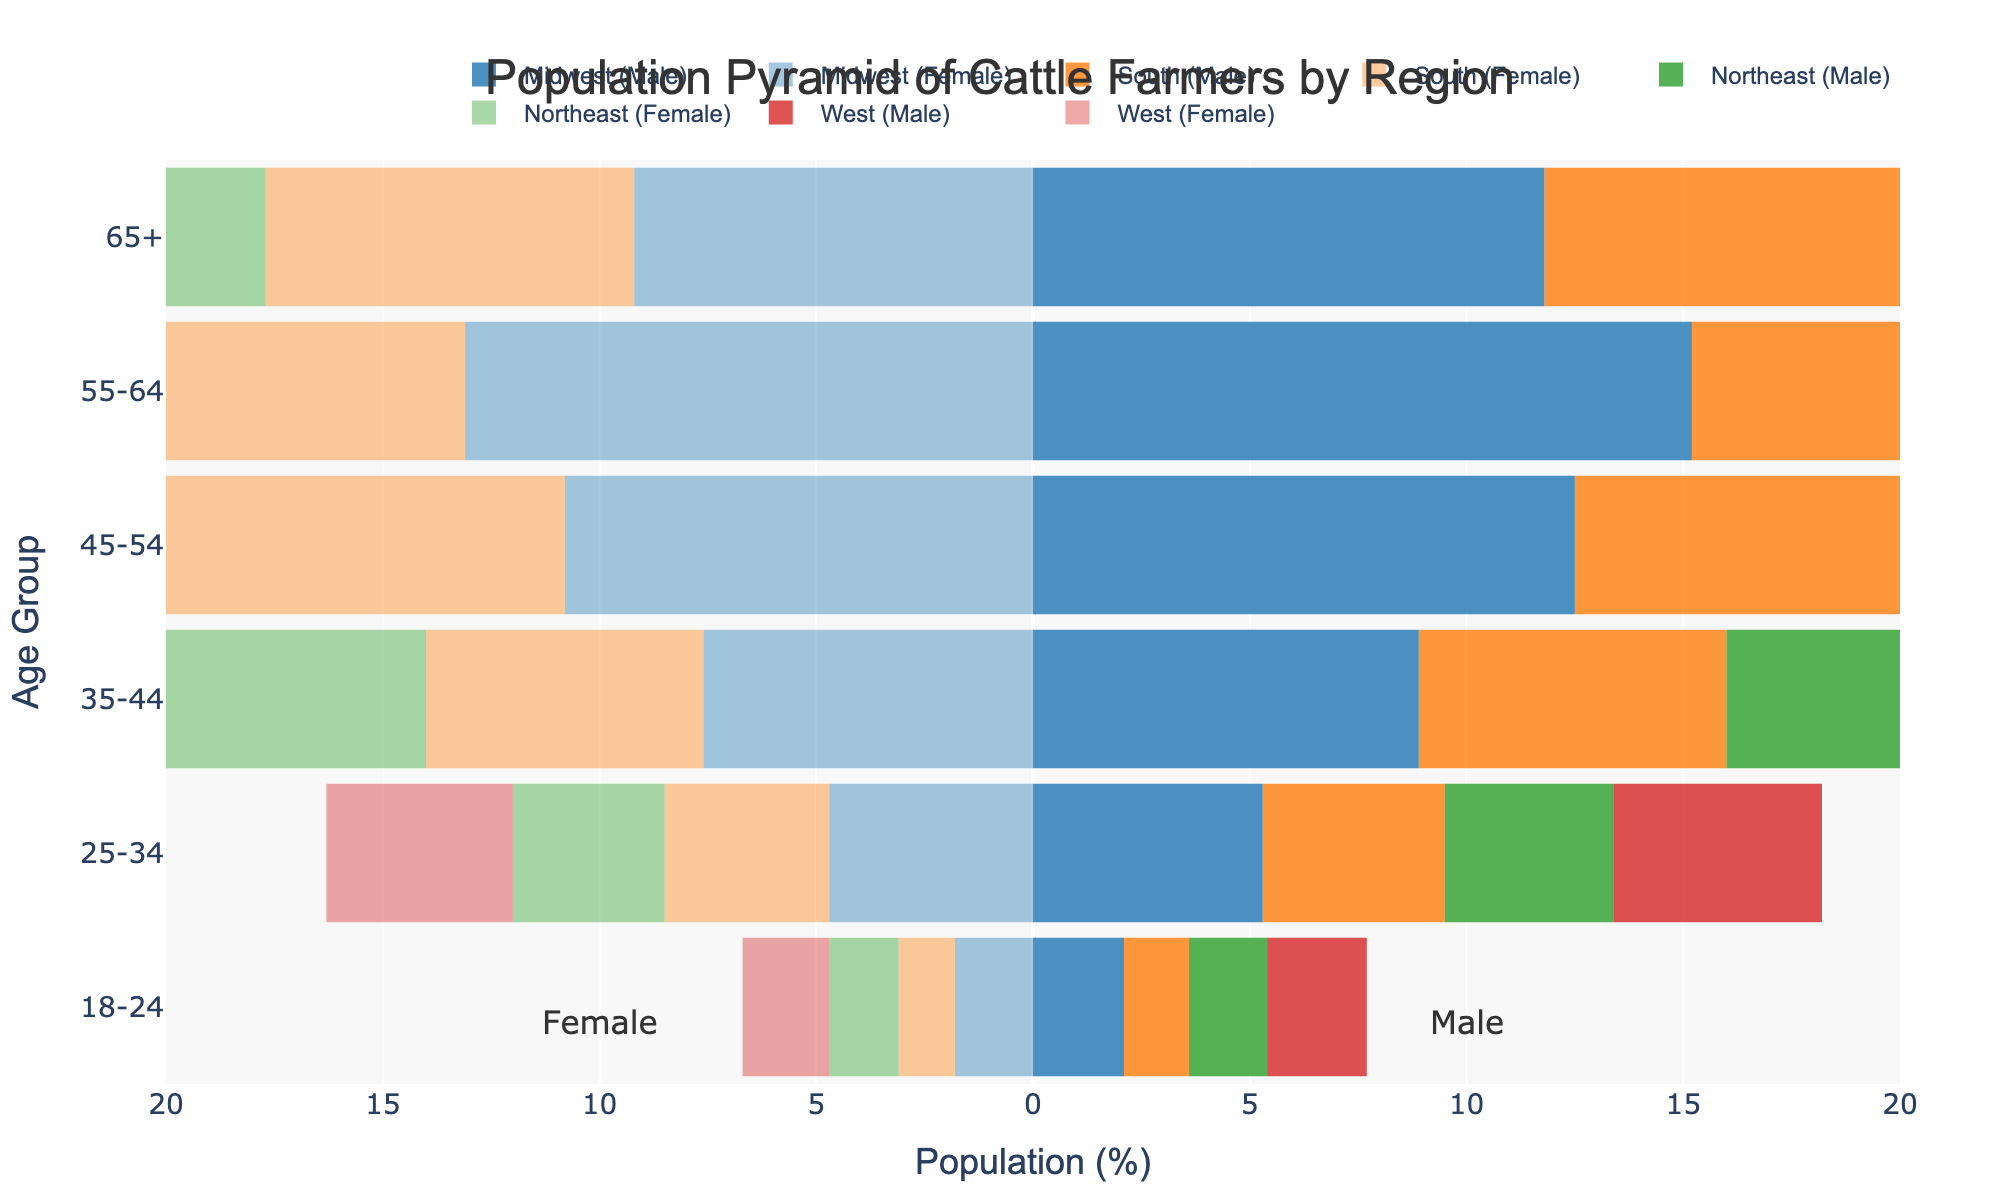How many age groups are displayed in the figure? Count the number of distinct age groups listed on the vertical axis. There are six age groups: '18-24', '25-34', '35-44', '45-54', '55-64', and '65+'.
Answer: 6 Which region has the highest percentage of male cattle farmers in the 55-64 age group? Look at the bars representing male data in the 55-64 age group and compare the values for all regions. The West has the highest percentage with 14.1%.
Answer: West Compare the percentage of female cattle farmers aged 18-24 in the Midwest and the South. Which region has more? Refer to the female data for the 18-24 age group in the Midwest and the South. Midwest has 1.8%, while South has 1.3%. Midwest has more.
Answer: Midwest What is the total percentage of male cattle farmers in the 45-54 age group for all regions combined? Add up the percentages of male cattle farmers in the 45-54 age group for each region: 12.5 (Midwest) + 10.6 (South) + 9.7 (Northeast) + 11.2 (West). The total is 44.
Answer: 44 Does the Northeast have a higher percentage of female cattle farmers in the 35-44 or the 25-34 age group? Compare the female percentages for the 35-44 and 25-34 age groups in the Northeast. The 35-44 age group is at 6.1%, while the 25-34 age group is at 3.5%.
Answer: 35-44 What gender and age group has the highest percentage in the West region? Look for the longest bar in the West region for both male and female data. The male cattle farmers in the 55-64 age group have the highest percentage at 14.1%.
Answer: Male, 55-64 How does the percentage of male farmers aged 65+ in the Northeast compare to those in the Midwest? Compare the male percentages in the 65+ age group between the Northeast (9.5%) and the Midwest (11.8%). The Midwest has a higher percentage.
Answer: Midwest What is the combined percentage of female cattle farmers aged 55-64 in the Midwest and the South? Add the percentage values for female cattle farmers aged 55-64 in the Midwest and South: 13.1 (Midwest) + 11.9 (South). The total is 25.
Answer: 25 Which age group has the least percentage representation of female cattle farmers across all regions? Look at the female percentages for each age group for all regions and identify the lowest. The 18-24 age group has the lowest percentages, ranging between 1.3% and 2.0%.
Answer: 18-24 